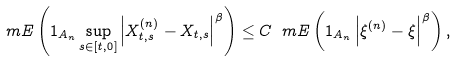<formula> <loc_0><loc_0><loc_500><loc_500>\ m E \left ( 1 _ { A _ { n } } \sup _ { s \in [ t , 0 ] } \left | X ^ { ( n ) } _ { t , s } - X _ { t , s } \right | ^ { \beta } \right ) \leq C \ m E \left ( 1 _ { A _ { n } } \left | \xi ^ { ( n ) } - \xi \right | ^ { \beta } \right ) ,</formula> 